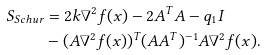Convert formula to latex. <formula><loc_0><loc_0><loc_500><loc_500>S _ { S c h u r } & = 2 k \nabla ^ { 2 } f ( x ) - 2 A ^ { T } A - q _ { 1 } I \\ & - ( A \nabla ^ { 2 } f ( x ) ) ^ { T } ( A A ^ { T } ) ^ { - 1 } A \nabla ^ { 2 } f ( x ) .</formula> 